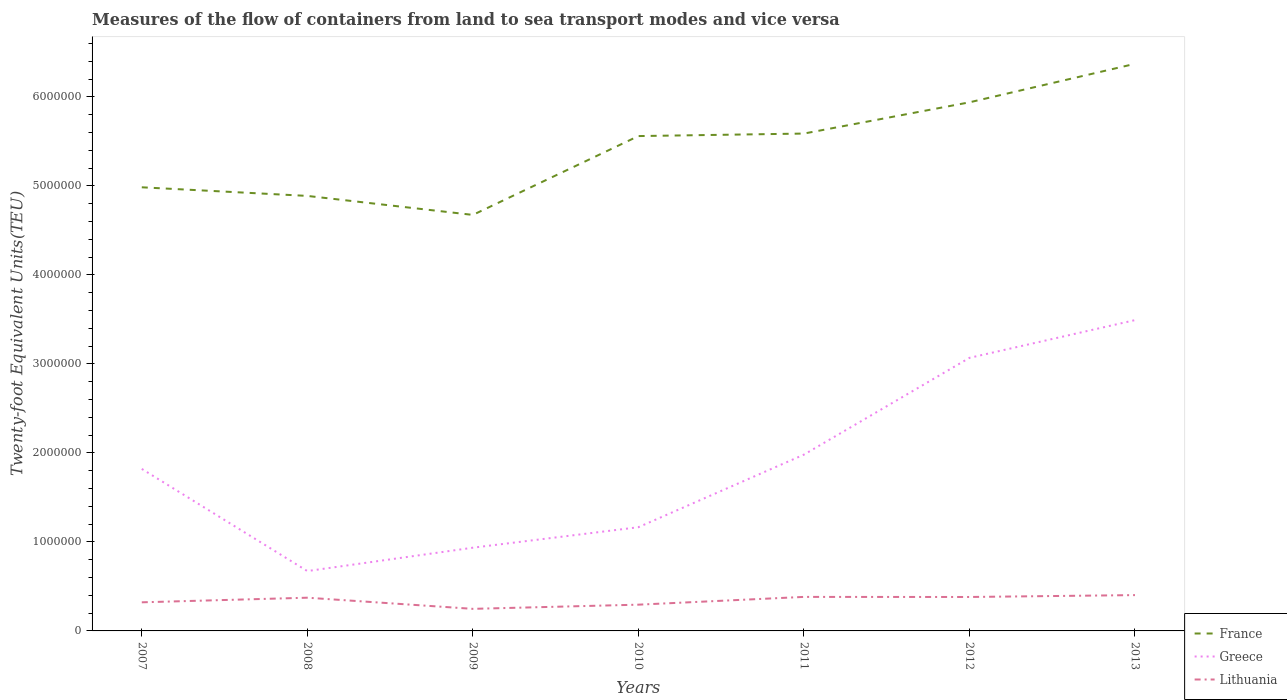How many different coloured lines are there?
Your answer should be compact. 3. Does the line corresponding to Greece intersect with the line corresponding to France?
Make the answer very short. No. Across all years, what is the maximum container port traffic in Lithuania?
Ensure brevity in your answer.  2.48e+05. What is the total container port traffic in France in the graph?
Provide a succinct answer. -3.79e+05. What is the difference between the highest and the second highest container port traffic in France?
Provide a succinct answer. 1.70e+06. How many lines are there?
Your answer should be very brief. 3. Does the graph contain grids?
Your answer should be compact. No. Where does the legend appear in the graph?
Provide a short and direct response. Bottom right. How many legend labels are there?
Your answer should be very brief. 3. How are the legend labels stacked?
Keep it short and to the point. Vertical. What is the title of the graph?
Your answer should be very brief. Measures of the flow of containers from land to sea transport modes and vice versa. Does "United Arab Emirates" appear as one of the legend labels in the graph?
Your answer should be compact. No. What is the label or title of the X-axis?
Your answer should be very brief. Years. What is the label or title of the Y-axis?
Give a very brief answer. Twenty-foot Equivalent Units(TEU). What is the Twenty-foot Equivalent Units(TEU) of France in 2007?
Make the answer very short. 4.98e+06. What is the Twenty-foot Equivalent Units(TEU) in Greece in 2007?
Ensure brevity in your answer.  1.82e+06. What is the Twenty-foot Equivalent Units(TEU) of Lithuania in 2007?
Offer a very short reply. 3.21e+05. What is the Twenty-foot Equivalent Units(TEU) in France in 2008?
Give a very brief answer. 4.89e+06. What is the Twenty-foot Equivalent Units(TEU) in Greece in 2008?
Offer a very short reply. 6.73e+05. What is the Twenty-foot Equivalent Units(TEU) in Lithuania in 2008?
Provide a succinct answer. 3.73e+05. What is the Twenty-foot Equivalent Units(TEU) of France in 2009?
Your answer should be very brief. 4.67e+06. What is the Twenty-foot Equivalent Units(TEU) of Greece in 2009?
Keep it short and to the point. 9.35e+05. What is the Twenty-foot Equivalent Units(TEU) of Lithuania in 2009?
Your answer should be very brief. 2.48e+05. What is the Twenty-foot Equivalent Units(TEU) in France in 2010?
Your answer should be very brief. 5.56e+06. What is the Twenty-foot Equivalent Units(TEU) of Greece in 2010?
Your answer should be very brief. 1.17e+06. What is the Twenty-foot Equivalent Units(TEU) of Lithuania in 2010?
Keep it short and to the point. 2.95e+05. What is the Twenty-foot Equivalent Units(TEU) of France in 2011?
Offer a terse response. 5.59e+06. What is the Twenty-foot Equivalent Units(TEU) in Greece in 2011?
Keep it short and to the point. 1.98e+06. What is the Twenty-foot Equivalent Units(TEU) in Lithuania in 2011?
Provide a short and direct response. 3.82e+05. What is the Twenty-foot Equivalent Units(TEU) of France in 2012?
Keep it short and to the point. 5.94e+06. What is the Twenty-foot Equivalent Units(TEU) of Greece in 2012?
Keep it short and to the point. 3.07e+06. What is the Twenty-foot Equivalent Units(TEU) in Lithuania in 2012?
Your answer should be very brief. 3.81e+05. What is the Twenty-foot Equivalent Units(TEU) of France in 2013?
Ensure brevity in your answer.  6.37e+06. What is the Twenty-foot Equivalent Units(TEU) of Greece in 2013?
Your response must be concise. 3.49e+06. What is the Twenty-foot Equivalent Units(TEU) of Lithuania in 2013?
Your answer should be compact. 4.02e+05. Across all years, what is the maximum Twenty-foot Equivalent Units(TEU) in France?
Ensure brevity in your answer.  6.37e+06. Across all years, what is the maximum Twenty-foot Equivalent Units(TEU) in Greece?
Give a very brief answer. 3.49e+06. Across all years, what is the maximum Twenty-foot Equivalent Units(TEU) in Lithuania?
Ensure brevity in your answer.  4.02e+05. Across all years, what is the minimum Twenty-foot Equivalent Units(TEU) in France?
Provide a succinct answer. 4.67e+06. Across all years, what is the minimum Twenty-foot Equivalent Units(TEU) in Greece?
Make the answer very short. 6.73e+05. Across all years, what is the minimum Twenty-foot Equivalent Units(TEU) of Lithuania?
Offer a terse response. 2.48e+05. What is the total Twenty-foot Equivalent Units(TEU) of France in the graph?
Your response must be concise. 3.80e+07. What is the total Twenty-foot Equivalent Units(TEU) in Greece in the graph?
Offer a terse response. 1.31e+07. What is the total Twenty-foot Equivalent Units(TEU) of Lithuania in the graph?
Ensure brevity in your answer.  2.40e+06. What is the difference between the Twenty-foot Equivalent Units(TEU) of France in 2007 and that in 2008?
Make the answer very short. 9.68e+04. What is the difference between the Twenty-foot Equivalent Units(TEU) in Greece in 2007 and that in 2008?
Offer a very short reply. 1.15e+06. What is the difference between the Twenty-foot Equivalent Units(TEU) in Lithuania in 2007 and that in 2008?
Offer a terse response. -5.18e+04. What is the difference between the Twenty-foot Equivalent Units(TEU) in France in 2007 and that in 2009?
Ensure brevity in your answer.  3.10e+05. What is the difference between the Twenty-foot Equivalent Units(TEU) of Greece in 2007 and that in 2009?
Offer a very short reply. 8.85e+05. What is the difference between the Twenty-foot Equivalent Units(TEU) in Lithuania in 2007 and that in 2009?
Give a very brief answer. 7.34e+04. What is the difference between the Twenty-foot Equivalent Units(TEU) of France in 2007 and that in 2010?
Keep it short and to the point. -5.75e+05. What is the difference between the Twenty-foot Equivalent Units(TEU) of Greece in 2007 and that in 2010?
Your answer should be very brief. 6.55e+05. What is the difference between the Twenty-foot Equivalent Units(TEU) in Lithuania in 2007 and that in 2010?
Provide a short and direct response. 2.65e+04. What is the difference between the Twenty-foot Equivalent Units(TEU) in France in 2007 and that in 2011?
Keep it short and to the point. -6.04e+05. What is the difference between the Twenty-foot Equivalent Units(TEU) in Greece in 2007 and that in 2011?
Provide a succinct answer. -1.60e+05. What is the difference between the Twenty-foot Equivalent Units(TEU) in Lithuania in 2007 and that in 2011?
Offer a terse response. -6.08e+04. What is the difference between the Twenty-foot Equivalent Units(TEU) in France in 2007 and that in 2012?
Your answer should be compact. -9.55e+05. What is the difference between the Twenty-foot Equivalent Units(TEU) of Greece in 2007 and that in 2012?
Give a very brief answer. -1.25e+06. What is the difference between the Twenty-foot Equivalent Units(TEU) in Lithuania in 2007 and that in 2012?
Provide a succinct answer. -5.99e+04. What is the difference between the Twenty-foot Equivalent Units(TEU) in France in 2007 and that in 2013?
Your answer should be very brief. -1.39e+06. What is the difference between the Twenty-foot Equivalent Units(TEU) of Greece in 2007 and that in 2013?
Offer a very short reply. -1.67e+06. What is the difference between the Twenty-foot Equivalent Units(TEU) of Lithuania in 2007 and that in 2013?
Keep it short and to the point. -8.11e+04. What is the difference between the Twenty-foot Equivalent Units(TEU) of France in 2008 and that in 2009?
Provide a short and direct response. 2.14e+05. What is the difference between the Twenty-foot Equivalent Units(TEU) in Greece in 2008 and that in 2009?
Your answer should be very brief. -2.63e+05. What is the difference between the Twenty-foot Equivalent Units(TEU) in Lithuania in 2008 and that in 2009?
Ensure brevity in your answer.  1.25e+05. What is the difference between the Twenty-foot Equivalent Units(TEU) in France in 2008 and that in 2010?
Offer a terse response. -6.72e+05. What is the difference between the Twenty-foot Equivalent Units(TEU) in Greece in 2008 and that in 2010?
Your response must be concise. -4.93e+05. What is the difference between the Twenty-foot Equivalent Units(TEU) of Lithuania in 2008 and that in 2010?
Ensure brevity in your answer.  7.83e+04. What is the difference between the Twenty-foot Equivalent Units(TEU) of France in 2008 and that in 2011?
Your answer should be very brief. -7.01e+05. What is the difference between the Twenty-foot Equivalent Units(TEU) in Greece in 2008 and that in 2011?
Your answer should be very brief. -1.31e+06. What is the difference between the Twenty-foot Equivalent Units(TEU) of Lithuania in 2008 and that in 2011?
Offer a terse response. -8937. What is the difference between the Twenty-foot Equivalent Units(TEU) in France in 2008 and that in 2012?
Give a very brief answer. -1.05e+06. What is the difference between the Twenty-foot Equivalent Units(TEU) of Greece in 2008 and that in 2012?
Ensure brevity in your answer.  -2.40e+06. What is the difference between the Twenty-foot Equivalent Units(TEU) in Lithuania in 2008 and that in 2012?
Provide a short and direct response. -8037. What is the difference between the Twenty-foot Equivalent Units(TEU) of France in 2008 and that in 2013?
Ensure brevity in your answer.  -1.48e+06. What is the difference between the Twenty-foot Equivalent Units(TEU) of Greece in 2008 and that in 2013?
Ensure brevity in your answer.  -2.82e+06. What is the difference between the Twenty-foot Equivalent Units(TEU) of Lithuania in 2008 and that in 2013?
Offer a very short reply. -2.92e+04. What is the difference between the Twenty-foot Equivalent Units(TEU) of France in 2009 and that in 2010?
Ensure brevity in your answer.  -8.86e+05. What is the difference between the Twenty-foot Equivalent Units(TEU) in Greece in 2009 and that in 2010?
Provide a short and direct response. -2.30e+05. What is the difference between the Twenty-foot Equivalent Units(TEU) of Lithuania in 2009 and that in 2010?
Keep it short and to the point. -4.70e+04. What is the difference between the Twenty-foot Equivalent Units(TEU) in France in 2009 and that in 2011?
Keep it short and to the point. -9.14e+05. What is the difference between the Twenty-foot Equivalent Units(TEU) of Greece in 2009 and that in 2011?
Your response must be concise. -1.05e+06. What is the difference between the Twenty-foot Equivalent Units(TEU) in Lithuania in 2009 and that in 2011?
Provide a succinct answer. -1.34e+05. What is the difference between the Twenty-foot Equivalent Units(TEU) of France in 2009 and that in 2012?
Your answer should be very brief. -1.26e+06. What is the difference between the Twenty-foot Equivalent Units(TEU) in Greece in 2009 and that in 2012?
Make the answer very short. -2.13e+06. What is the difference between the Twenty-foot Equivalent Units(TEU) of Lithuania in 2009 and that in 2012?
Make the answer very short. -1.33e+05. What is the difference between the Twenty-foot Equivalent Units(TEU) of France in 2009 and that in 2013?
Ensure brevity in your answer.  -1.70e+06. What is the difference between the Twenty-foot Equivalent Units(TEU) of Greece in 2009 and that in 2013?
Make the answer very short. -2.56e+06. What is the difference between the Twenty-foot Equivalent Units(TEU) in Lithuania in 2009 and that in 2013?
Ensure brevity in your answer.  -1.55e+05. What is the difference between the Twenty-foot Equivalent Units(TEU) of France in 2010 and that in 2011?
Your answer should be compact. -2.83e+04. What is the difference between the Twenty-foot Equivalent Units(TEU) in Greece in 2010 and that in 2011?
Your answer should be very brief. -8.15e+05. What is the difference between the Twenty-foot Equivalent Units(TEU) in Lithuania in 2010 and that in 2011?
Offer a very short reply. -8.72e+04. What is the difference between the Twenty-foot Equivalent Units(TEU) in France in 2010 and that in 2012?
Offer a terse response. -3.79e+05. What is the difference between the Twenty-foot Equivalent Units(TEU) of Greece in 2010 and that in 2012?
Your response must be concise. -1.90e+06. What is the difference between the Twenty-foot Equivalent Units(TEU) in Lithuania in 2010 and that in 2012?
Provide a short and direct response. -8.63e+04. What is the difference between the Twenty-foot Equivalent Units(TEU) of France in 2010 and that in 2013?
Offer a terse response. -8.12e+05. What is the difference between the Twenty-foot Equivalent Units(TEU) in Greece in 2010 and that in 2013?
Offer a very short reply. -2.33e+06. What is the difference between the Twenty-foot Equivalent Units(TEU) in Lithuania in 2010 and that in 2013?
Keep it short and to the point. -1.08e+05. What is the difference between the Twenty-foot Equivalent Units(TEU) in France in 2011 and that in 2012?
Your answer should be compact. -3.51e+05. What is the difference between the Twenty-foot Equivalent Units(TEU) in Greece in 2011 and that in 2012?
Your answer should be very brief. -1.09e+06. What is the difference between the Twenty-foot Equivalent Units(TEU) of Lithuania in 2011 and that in 2012?
Your answer should be compact. 900. What is the difference between the Twenty-foot Equivalent Units(TEU) of France in 2011 and that in 2013?
Provide a succinct answer. -7.83e+05. What is the difference between the Twenty-foot Equivalent Units(TEU) in Greece in 2011 and that in 2013?
Offer a terse response. -1.51e+06. What is the difference between the Twenty-foot Equivalent Units(TEU) of Lithuania in 2011 and that in 2013?
Provide a succinct answer. -2.03e+04. What is the difference between the Twenty-foot Equivalent Units(TEU) of France in 2012 and that in 2013?
Your answer should be very brief. -4.33e+05. What is the difference between the Twenty-foot Equivalent Units(TEU) of Greece in 2012 and that in 2013?
Provide a short and direct response. -4.24e+05. What is the difference between the Twenty-foot Equivalent Units(TEU) of Lithuania in 2012 and that in 2013?
Make the answer very short. -2.12e+04. What is the difference between the Twenty-foot Equivalent Units(TEU) in France in 2007 and the Twenty-foot Equivalent Units(TEU) in Greece in 2008?
Your response must be concise. 4.31e+06. What is the difference between the Twenty-foot Equivalent Units(TEU) in France in 2007 and the Twenty-foot Equivalent Units(TEU) in Lithuania in 2008?
Give a very brief answer. 4.61e+06. What is the difference between the Twenty-foot Equivalent Units(TEU) of Greece in 2007 and the Twenty-foot Equivalent Units(TEU) of Lithuania in 2008?
Provide a succinct answer. 1.45e+06. What is the difference between the Twenty-foot Equivalent Units(TEU) in France in 2007 and the Twenty-foot Equivalent Units(TEU) in Greece in 2009?
Provide a succinct answer. 4.05e+06. What is the difference between the Twenty-foot Equivalent Units(TEU) in France in 2007 and the Twenty-foot Equivalent Units(TEU) in Lithuania in 2009?
Provide a short and direct response. 4.74e+06. What is the difference between the Twenty-foot Equivalent Units(TEU) of Greece in 2007 and the Twenty-foot Equivalent Units(TEU) of Lithuania in 2009?
Your answer should be very brief. 1.57e+06. What is the difference between the Twenty-foot Equivalent Units(TEU) in France in 2007 and the Twenty-foot Equivalent Units(TEU) in Greece in 2010?
Offer a very short reply. 3.82e+06. What is the difference between the Twenty-foot Equivalent Units(TEU) of France in 2007 and the Twenty-foot Equivalent Units(TEU) of Lithuania in 2010?
Make the answer very short. 4.69e+06. What is the difference between the Twenty-foot Equivalent Units(TEU) of Greece in 2007 and the Twenty-foot Equivalent Units(TEU) of Lithuania in 2010?
Provide a succinct answer. 1.53e+06. What is the difference between the Twenty-foot Equivalent Units(TEU) in France in 2007 and the Twenty-foot Equivalent Units(TEU) in Greece in 2011?
Provide a succinct answer. 3.00e+06. What is the difference between the Twenty-foot Equivalent Units(TEU) of France in 2007 and the Twenty-foot Equivalent Units(TEU) of Lithuania in 2011?
Provide a short and direct response. 4.60e+06. What is the difference between the Twenty-foot Equivalent Units(TEU) of Greece in 2007 and the Twenty-foot Equivalent Units(TEU) of Lithuania in 2011?
Your answer should be very brief. 1.44e+06. What is the difference between the Twenty-foot Equivalent Units(TEU) in France in 2007 and the Twenty-foot Equivalent Units(TEU) in Greece in 2012?
Provide a short and direct response. 1.92e+06. What is the difference between the Twenty-foot Equivalent Units(TEU) in France in 2007 and the Twenty-foot Equivalent Units(TEU) in Lithuania in 2012?
Your response must be concise. 4.60e+06. What is the difference between the Twenty-foot Equivalent Units(TEU) of Greece in 2007 and the Twenty-foot Equivalent Units(TEU) of Lithuania in 2012?
Give a very brief answer. 1.44e+06. What is the difference between the Twenty-foot Equivalent Units(TEU) in France in 2007 and the Twenty-foot Equivalent Units(TEU) in Greece in 2013?
Offer a terse response. 1.49e+06. What is the difference between the Twenty-foot Equivalent Units(TEU) of France in 2007 and the Twenty-foot Equivalent Units(TEU) of Lithuania in 2013?
Make the answer very short. 4.58e+06. What is the difference between the Twenty-foot Equivalent Units(TEU) of Greece in 2007 and the Twenty-foot Equivalent Units(TEU) of Lithuania in 2013?
Offer a very short reply. 1.42e+06. What is the difference between the Twenty-foot Equivalent Units(TEU) in France in 2008 and the Twenty-foot Equivalent Units(TEU) in Greece in 2009?
Your answer should be compact. 3.95e+06. What is the difference between the Twenty-foot Equivalent Units(TEU) of France in 2008 and the Twenty-foot Equivalent Units(TEU) of Lithuania in 2009?
Provide a succinct answer. 4.64e+06. What is the difference between the Twenty-foot Equivalent Units(TEU) in Greece in 2008 and the Twenty-foot Equivalent Units(TEU) in Lithuania in 2009?
Make the answer very short. 4.25e+05. What is the difference between the Twenty-foot Equivalent Units(TEU) in France in 2008 and the Twenty-foot Equivalent Units(TEU) in Greece in 2010?
Your response must be concise. 3.72e+06. What is the difference between the Twenty-foot Equivalent Units(TEU) of France in 2008 and the Twenty-foot Equivalent Units(TEU) of Lithuania in 2010?
Make the answer very short. 4.59e+06. What is the difference between the Twenty-foot Equivalent Units(TEU) of Greece in 2008 and the Twenty-foot Equivalent Units(TEU) of Lithuania in 2010?
Give a very brief answer. 3.78e+05. What is the difference between the Twenty-foot Equivalent Units(TEU) of France in 2008 and the Twenty-foot Equivalent Units(TEU) of Greece in 2011?
Provide a short and direct response. 2.91e+06. What is the difference between the Twenty-foot Equivalent Units(TEU) in France in 2008 and the Twenty-foot Equivalent Units(TEU) in Lithuania in 2011?
Provide a short and direct response. 4.51e+06. What is the difference between the Twenty-foot Equivalent Units(TEU) in Greece in 2008 and the Twenty-foot Equivalent Units(TEU) in Lithuania in 2011?
Offer a very short reply. 2.90e+05. What is the difference between the Twenty-foot Equivalent Units(TEU) in France in 2008 and the Twenty-foot Equivalent Units(TEU) in Greece in 2012?
Make the answer very short. 1.82e+06. What is the difference between the Twenty-foot Equivalent Units(TEU) in France in 2008 and the Twenty-foot Equivalent Units(TEU) in Lithuania in 2012?
Your answer should be compact. 4.51e+06. What is the difference between the Twenty-foot Equivalent Units(TEU) of Greece in 2008 and the Twenty-foot Equivalent Units(TEU) of Lithuania in 2012?
Keep it short and to the point. 2.91e+05. What is the difference between the Twenty-foot Equivalent Units(TEU) in France in 2008 and the Twenty-foot Equivalent Units(TEU) in Greece in 2013?
Make the answer very short. 1.40e+06. What is the difference between the Twenty-foot Equivalent Units(TEU) in France in 2008 and the Twenty-foot Equivalent Units(TEU) in Lithuania in 2013?
Ensure brevity in your answer.  4.49e+06. What is the difference between the Twenty-foot Equivalent Units(TEU) of Greece in 2008 and the Twenty-foot Equivalent Units(TEU) of Lithuania in 2013?
Provide a short and direct response. 2.70e+05. What is the difference between the Twenty-foot Equivalent Units(TEU) in France in 2009 and the Twenty-foot Equivalent Units(TEU) in Greece in 2010?
Your answer should be very brief. 3.51e+06. What is the difference between the Twenty-foot Equivalent Units(TEU) of France in 2009 and the Twenty-foot Equivalent Units(TEU) of Lithuania in 2010?
Make the answer very short. 4.38e+06. What is the difference between the Twenty-foot Equivalent Units(TEU) of Greece in 2009 and the Twenty-foot Equivalent Units(TEU) of Lithuania in 2010?
Your answer should be very brief. 6.40e+05. What is the difference between the Twenty-foot Equivalent Units(TEU) in France in 2009 and the Twenty-foot Equivalent Units(TEU) in Greece in 2011?
Ensure brevity in your answer.  2.69e+06. What is the difference between the Twenty-foot Equivalent Units(TEU) in France in 2009 and the Twenty-foot Equivalent Units(TEU) in Lithuania in 2011?
Ensure brevity in your answer.  4.29e+06. What is the difference between the Twenty-foot Equivalent Units(TEU) in Greece in 2009 and the Twenty-foot Equivalent Units(TEU) in Lithuania in 2011?
Make the answer very short. 5.53e+05. What is the difference between the Twenty-foot Equivalent Units(TEU) of France in 2009 and the Twenty-foot Equivalent Units(TEU) of Greece in 2012?
Make the answer very short. 1.61e+06. What is the difference between the Twenty-foot Equivalent Units(TEU) of France in 2009 and the Twenty-foot Equivalent Units(TEU) of Lithuania in 2012?
Provide a short and direct response. 4.29e+06. What is the difference between the Twenty-foot Equivalent Units(TEU) in Greece in 2009 and the Twenty-foot Equivalent Units(TEU) in Lithuania in 2012?
Your answer should be compact. 5.54e+05. What is the difference between the Twenty-foot Equivalent Units(TEU) in France in 2009 and the Twenty-foot Equivalent Units(TEU) in Greece in 2013?
Offer a terse response. 1.18e+06. What is the difference between the Twenty-foot Equivalent Units(TEU) of France in 2009 and the Twenty-foot Equivalent Units(TEU) of Lithuania in 2013?
Provide a short and direct response. 4.27e+06. What is the difference between the Twenty-foot Equivalent Units(TEU) in Greece in 2009 and the Twenty-foot Equivalent Units(TEU) in Lithuania in 2013?
Your answer should be very brief. 5.33e+05. What is the difference between the Twenty-foot Equivalent Units(TEU) in France in 2010 and the Twenty-foot Equivalent Units(TEU) in Greece in 2011?
Provide a succinct answer. 3.58e+06. What is the difference between the Twenty-foot Equivalent Units(TEU) of France in 2010 and the Twenty-foot Equivalent Units(TEU) of Lithuania in 2011?
Your response must be concise. 5.18e+06. What is the difference between the Twenty-foot Equivalent Units(TEU) of Greece in 2010 and the Twenty-foot Equivalent Units(TEU) of Lithuania in 2011?
Keep it short and to the point. 7.83e+05. What is the difference between the Twenty-foot Equivalent Units(TEU) of France in 2010 and the Twenty-foot Equivalent Units(TEU) of Greece in 2012?
Your answer should be compact. 2.49e+06. What is the difference between the Twenty-foot Equivalent Units(TEU) in France in 2010 and the Twenty-foot Equivalent Units(TEU) in Lithuania in 2012?
Ensure brevity in your answer.  5.18e+06. What is the difference between the Twenty-foot Equivalent Units(TEU) in Greece in 2010 and the Twenty-foot Equivalent Units(TEU) in Lithuania in 2012?
Your response must be concise. 7.84e+05. What is the difference between the Twenty-foot Equivalent Units(TEU) of France in 2010 and the Twenty-foot Equivalent Units(TEU) of Greece in 2013?
Provide a short and direct response. 2.07e+06. What is the difference between the Twenty-foot Equivalent Units(TEU) of France in 2010 and the Twenty-foot Equivalent Units(TEU) of Lithuania in 2013?
Provide a succinct answer. 5.16e+06. What is the difference between the Twenty-foot Equivalent Units(TEU) of Greece in 2010 and the Twenty-foot Equivalent Units(TEU) of Lithuania in 2013?
Give a very brief answer. 7.63e+05. What is the difference between the Twenty-foot Equivalent Units(TEU) in France in 2011 and the Twenty-foot Equivalent Units(TEU) in Greece in 2012?
Offer a very short reply. 2.52e+06. What is the difference between the Twenty-foot Equivalent Units(TEU) of France in 2011 and the Twenty-foot Equivalent Units(TEU) of Lithuania in 2012?
Offer a terse response. 5.21e+06. What is the difference between the Twenty-foot Equivalent Units(TEU) in Greece in 2011 and the Twenty-foot Equivalent Units(TEU) in Lithuania in 2012?
Offer a very short reply. 1.60e+06. What is the difference between the Twenty-foot Equivalent Units(TEU) in France in 2011 and the Twenty-foot Equivalent Units(TEU) in Greece in 2013?
Offer a very short reply. 2.10e+06. What is the difference between the Twenty-foot Equivalent Units(TEU) in France in 2011 and the Twenty-foot Equivalent Units(TEU) in Lithuania in 2013?
Make the answer very short. 5.19e+06. What is the difference between the Twenty-foot Equivalent Units(TEU) in Greece in 2011 and the Twenty-foot Equivalent Units(TEU) in Lithuania in 2013?
Offer a very short reply. 1.58e+06. What is the difference between the Twenty-foot Equivalent Units(TEU) in France in 2012 and the Twenty-foot Equivalent Units(TEU) in Greece in 2013?
Your answer should be compact. 2.45e+06. What is the difference between the Twenty-foot Equivalent Units(TEU) in France in 2012 and the Twenty-foot Equivalent Units(TEU) in Lithuania in 2013?
Your response must be concise. 5.54e+06. What is the difference between the Twenty-foot Equivalent Units(TEU) in Greece in 2012 and the Twenty-foot Equivalent Units(TEU) in Lithuania in 2013?
Keep it short and to the point. 2.67e+06. What is the average Twenty-foot Equivalent Units(TEU) of France per year?
Give a very brief answer. 5.43e+06. What is the average Twenty-foot Equivalent Units(TEU) in Greece per year?
Offer a terse response. 1.88e+06. What is the average Twenty-foot Equivalent Units(TEU) in Lithuania per year?
Your answer should be very brief. 3.43e+05. In the year 2007, what is the difference between the Twenty-foot Equivalent Units(TEU) of France and Twenty-foot Equivalent Units(TEU) of Greece?
Keep it short and to the point. 3.16e+06. In the year 2007, what is the difference between the Twenty-foot Equivalent Units(TEU) of France and Twenty-foot Equivalent Units(TEU) of Lithuania?
Make the answer very short. 4.66e+06. In the year 2007, what is the difference between the Twenty-foot Equivalent Units(TEU) of Greece and Twenty-foot Equivalent Units(TEU) of Lithuania?
Ensure brevity in your answer.  1.50e+06. In the year 2008, what is the difference between the Twenty-foot Equivalent Units(TEU) of France and Twenty-foot Equivalent Units(TEU) of Greece?
Your response must be concise. 4.22e+06. In the year 2008, what is the difference between the Twenty-foot Equivalent Units(TEU) in France and Twenty-foot Equivalent Units(TEU) in Lithuania?
Offer a terse response. 4.51e+06. In the year 2008, what is the difference between the Twenty-foot Equivalent Units(TEU) of Greece and Twenty-foot Equivalent Units(TEU) of Lithuania?
Provide a succinct answer. 2.99e+05. In the year 2009, what is the difference between the Twenty-foot Equivalent Units(TEU) in France and Twenty-foot Equivalent Units(TEU) in Greece?
Your answer should be very brief. 3.74e+06. In the year 2009, what is the difference between the Twenty-foot Equivalent Units(TEU) in France and Twenty-foot Equivalent Units(TEU) in Lithuania?
Make the answer very short. 4.43e+06. In the year 2009, what is the difference between the Twenty-foot Equivalent Units(TEU) in Greece and Twenty-foot Equivalent Units(TEU) in Lithuania?
Provide a succinct answer. 6.87e+05. In the year 2010, what is the difference between the Twenty-foot Equivalent Units(TEU) of France and Twenty-foot Equivalent Units(TEU) of Greece?
Provide a succinct answer. 4.39e+06. In the year 2010, what is the difference between the Twenty-foot Equivalent Units(TEU) of France and Twenty-foot Equivalent Units(TEU) of Lithuania?
Keep it short and to the point. 5.27e+06. In the year 2010, what is the difference between the Twenty-foot Equivalent Units(TEU) in Greece and Twenty-foot Equivalent Units(TEU) in Lithuania?
Provide a short and direct response. 8.70e+05. In the year 2011, what is the difference between the Twenty-foot Equivalent Units(TEU) of France and Twenty-foot Equivalent Units(TEU) of Greece?
Provide a short and direct response. 3.61e+06. In the year 2011, what is the difference between the Twenty-foot Equivalent Units(TEU) of France and Twenty-foot Equivalent Units(TEU) of Lithuania?
Give a very brief answer. 5.21e+06. In the year 2011, what is the difference between the Twenty-foot Equivalent Units(TEU) in Greece and Twenty-foot Equivalent Units(TEU) in Lithuania?
Ensure brevity in your answer.  1.60e+06. In the year 2012, what is the difference between the Twenty-foot Equivalent Units(TEU) in France and Twenty-foot Equivalent Units(TEU) in Greece?
Make the answer very short. 2.87e+06. In the year 2012, what is the difference between the Twenty-foot Equivalent Units(TEU) of France and Twenty-foot Equivalent Units(TEU) of Lithuania?
Offer a terse response. 5.56e+06. In the year 2012, what is the difference between the Twenty-foot Equivalent Units(TEU) in Greece and Twenty-foot Equivalent Units(TEU) in Lithuania?
Give a very brief answer. 2.69e+06. In the year 2013, what is the difference between the Twenty-foot Equivalent Units(TEU) of France and Twenty-foot Equivalent Units(TEU) of Greece?
Offer a very short reply. 2.88e+06. In the year 2013, what is the difference between the Twenty-foot Equivalent Units(TEU) in France and Twenty-foot Equivalent Units(TEU) in Lithuania?
Offer a very short reply. 5.97e+06. In the year 2013, what is the difference between the Twenty-foot Equivalent Units(TEU) of Greece and Twenty-foot Equivalent Units(TEU) of Lithuania?
Provide a short and direct response. 3.09e+06. What is the ratio of the Twenty-foot Equivalent Units(TEU) of France in 2007 to that in 2008?
Provide a short and direct response. 1.02. What is the ratio of the Twenty-foot Equivalent Units(TEU) in Greece in 2007 to that in 2008?
Provide a short and direct response. 2.71. What is the ratio of the Twenty-foot Equivalent Units(TEU) of Lithuania in 2007 to that in 2008?
Give a very brief answer. 0.86. What is the ratio of the Twenty-foot Equivalent Units(TEU) of France in 2007 to that in 2009?
Give a very brief answer. 1.07. What is the ratio of the Twenty-foot Equivalent Units(TEU) in Greece in 2007 to that in 2009?
Offer a very short reply. 1.95. What is the ratio of the Twenty-foot Equivalent Units(TEU) in Lithuania in 2007 to that in 2009?
Ensure brevity in your answer.  1.3. What is the ratio of the Twenty-foot Equivalent Units(TEU) in France in 2007 to that in 2010?
Your answer should be very brief. 0.9. What is the ratio of the Twenty-foot Equivalent Units(TEU) of Greece in 2007 to that in 2010?
Your response must be concise. 1.56. What is the ratio of the Twenty-foot Equivalent Units(TEU) in Lithuania in 2007 to that in 2010?
Make the answer very short. 1.09. What is the ratio of the Twenty-foot Equivalent Units(TEU) in France in 2007 to that in 2011?
Offer a terse response. 0.89. What is the ratio of the Twenty-foot Equivalent Units(TEU) of Greece in 2007 to that in 2011?
Your answer should be very brief. 0.92. What is the ratio of the Twenty-foot Equivalent Units(TEU) in Lithuania in 2007 to that in 2011?
Ensure brevity in your answer.  0.84. What is the ratio of the Twenty-foot Equivalent Units(TEU) in France in 2007 to that in 2012?
Give a very brief answer. 0.84. What is the ratio of the Twenty-foot Equivalent Units(TEU) in Greece in 2007 to that in 2012?
Give a very brief answer. 0.59. What is the ratio of the Twenty-foot Equivalent Units(TEU) of Lithuania in 2007 to that in 2012?
Make the answer very short. 0.84. What is the ratio of the Twenty-foot Equivalent Units(TEU) in France in 2007 to that in 2013?
Provide a short and direct response. 0.78. What is the ratio of the Twenty-foot Equivalent Units(TEU) of Greece in 2007 to that in 2013?
Give a very brief answer. 0.52. What is the ratio of the Twenty-foot Equivalent Units(TEU) in Lithuania in 2007 to that in 2013?
Your response must be concise. 0.8. What is the ratio of the Twenty-foot Equivalent Units(TEU) in France in 2008 to that in 2009?
Provide a short and direct response. 1.05. What is the ratio of the Twenty-foot Equivalent Units(TEU) in Greece in 2008 to that in 2009?
Keep it short and to the point. 0.72. What is the ratio of the Twenty-foot Equivalent Units(TEU) of Lithuania in 2008 to that in 2009?
Ensure brevity in your answer.  1.51. What is the ratio of the Twenty-foot Equivalent Units(TEU) in France in 2008 to that in 2010?
Make the answer very short. 0.88. What is the ratio of the Twenty-foot Equivalent Units(TEU) in Greece in 2008 to that in 2010?
Offer a terse response. 0.58. What is the ratio of the Twenty-foot Equivalent Units(TEU) of Lithuania in 2008 to that in 2010?
Give a very brief answer. 1.27. What is the ratio of the Twenty-foot Equivalent Units(TEU) of France in 2008 to that in 2011?
Your response must be concise. 0.87. What is the ratio of the Twenty-foot Equivalent Units(TEU) in Greece in 2008 to that in 2011?
Your answer should be compact. 0.34. What is the ratio of the Twenty-foot Equivalent Units(TEU) of Lithuania in 2008 to that in 2011?
Offer a very short reply. 0.98. What is the ratio of the Twenty-foot Equivalent Units(TEU) in France in 2008 to that in 2012?
Make the answer very short. 0.82. What is the ratio of the Twenty-foot Equivalent Units(TEU) of Greece in 2008 to that in 2012?
Make the answer very short. 0.22. What is the ratio of the Twenty-foot Equivalent Units(TEU) of Lithuania in 2008 to that in 2012?
Your answer should be compact. 0.98. What is the ratio of the Twenty-foot Equivalent Units(TEU) in France in 2008 to that in 2013?
Offer a terse response. 0.77. What is the ratio of the Twenty-foot Equivalent Units(TEU) in Greece in 2008 to that in 2013?
Ensure brevity in your answer.  0.19. What is the ratio of the Twenty-foot Equivalent Units(TEU) of Lithuania in 2008 to that in 2013?
Provide a short and direct response. 0.93. What is the ratio of the Twenty-foot Equivalent Units(TEU) in France in 2009 to that in 2010?
Ensure brevity in your answer.  0.84. What is the ratio of the Twenty-foot Equivalent Units(TEU) of Greece in 2009 to that in 2010?
Ensure brevity in your answer.  0.8. What is the ratio of the Twenty-foot Equivalent Units(TEU) in Lithuania in 2009 to that in 2010?
Ensure brevity in your answer.  0.84. What is the ratio of the Twenty-foot Equivalent Units(TEU) in France in 2009 to that in 2011?
Ensure brevity in your answer.  0.84. What is the ratio of the Twenty-foot Equivalent Units(TEU) in Greece in 2009 to that in 2011?
Your answer should be compact. 0.47. What is the ratio of the Twenty-foot Equivalent Units(TEU) in Lithuania in 2009 to that in 2011?
Keep it short and to the point. 0.65. What is the ratio of the Twenty-foot Equivalent Units(TEU) in France in 2009 to that in 2012?
Your answer should be compact. 0.79. What is the ratio of the Twenty-foot Equivalent Units(TEU) in Greece in 2009 to that in 2012?
Make the answer very short. 0.3. What is the ratio of the Twenty-foot Equivalent Units(TEU) in Lithuania in 2009 to that in 2012?
Offer a very short reply. 0.65. What is the ratio of the Twenty-foot Equivalent Units(TEU) in France in 2009 to that in 2013?
Provide a succinct answer. 0.73. What is the ratio of the Twenty-foot Equivalent Units(TEU) in Greece in 2009 to that in 2013?
Ensure brevity in your answer.  0.27. What is the ratio of the Twenty-foot Equivalent Units(TEU) of Lithuania in 2009 to that in 2013?
Give a very brief answer. 0.62. What is the ratio of the Twenty-foot Equivalent Units(TEU) in France in 2010 to that in 2011?
Keep it short and to the point. 0.99. What is the ratio of the Twenty-foot Equivalent Units(TEU) of Greece in 2010 to that in 2011?
Ensure brevity in your answer.  0.59. What is the ratio of the Twenty-foot Equivalent Units(TEU) of Lithuania in 2010 to that in 2011?
Keep it short and to the point. 0.77. What is the ratio of the Twenty-foot Equivalent Units(TEU) of France in 2010 to that in 2012?
Ensure brevity in your answer.  0.94. What is the ratio of the Twenty-foot Equivalent Units(TEU) of Greece in 2010 to that in 2012?
Offer a terse response. 0.38. What is the ratio of the Twenty-foot Equivalent Units(TEU) in Lithuania in 2010 to that in 2012?
Ensure brevity in your answer.  0.77. What is the ratio of the Twenty-foot Equivalent Units(TEU) of France in 2010 to that in 2013?
Offer a very short reply. 0.87. What is the ratio of the Twenty-foot Equivalent Units(TEU) in Greece in 2010 to that in 2013?
Offer a terse response. 0.33. What is the ratio of the Twenty-foot Equivalent Units(TEU) in Lithuania in 2010 to that in 2013?
Give a very brief answer. 0.73. What is the ratio of the Twenty-foot Equivalent Units(TEU) of France in 2011 to that in 2012?
Give a very brief answer. 0.94. What is the ratio of the Twenty-foot Equivalent Units(TEU) of Greece in 2011 to that in 2012?
Your response must be concise. 0.65. What is the ratio of the Twenty-foot Equivalent Units(TEU) of France in 2011 to that in 2013?
Keep it short and to the point. 0.88. What is the ratio of the Twenty-foot Equivalent Units(TEU) of Greece in 2011 to that in 2013?
Provide a succinct answer. 0.57. What is the ratio of the Twenty-foot Equivalent Units(TEU) of Lithuania in 2011 to that in 2013?
Offer a very short reply. 0.95. What is the ratio of the Twenty-foot Equivalent Units(TEU) of France in 2012 to that in 2013?
Keep it short and to the point. 0.93. What is the ratio of the Twenty-foot Equivalent Units(TEU) in Greece in 2012 to that in 2013?
Make the answer very short. 0.88. What is the ratio of the Twenty-foot Equivalent Units(TEU) of Lithuania in 2012 to that in 2013?
Provide a succinct answer. 0.95. What is the difference between the highest and the second highest Twenty-foot Equivalent Units(TEU) of France?
Provide a succinct answer. 4.33e+05. What is the difference between the highest and the second highest Twenty-foot Equivalent Units(TEU) in Greece?
Ensure brevity in your answer.  4.24e+05. What is the difference between the highest and the second highest Twenty-foot Equivalent Units(TEU) in Lithuania?
Provide a succinct answer. 2.03e+04. What is the difference between the highest and the lowest Twenty-foot Equivalent Units(TEU) in France?
Provide a short and direct response. 1.70e+06. What is the difference between the highest and the lowest Twenty-foot Equivalent Units(TEU) in Greece?
Ensure brevity in your answer.  2.82e+06. What is the difference between the highest and the lowest Twenty-foot Equivalent Units(TEU) in Lithuania?
Give a very brief answer. 1.55e+05. 